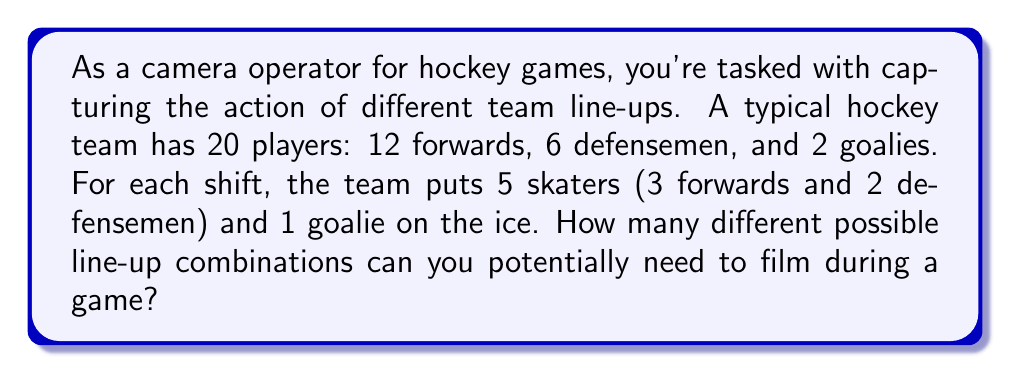Can you solve this math problem? Let's break this down step-by-step:

1) First, let's consider the forwards. We need to choose 3 out of 12 forwards.
   This can be done in $\binom{12}{3}$ ways.

2) For the defensemen, we need to choose 2 out of 6.
   This can be done in $\binom{6}{2}$ ways.

3) For the goalie, we need to choose 1 out of 2.
   This can be done in $\binom{2}{1}$ ways.

4) By the multiplication principle, the total number of possible line-ups is:

   $$ \binom{12}{3} \times \binom{6}{2} \times \binom{2}{1} $$

5) Let's calculate each combination:
   
   $\binom{12}{3} = \frac{12!}{3!(12-3)!} = \frac{12!}{3!9!} = 220$
   
   $\binom{6}{2} = \frac{6!}{2!(6-2)!} = \frac{6!}{2!4!} = 15$
   
   $\binom{2}{1} = \frac{2!}{1!(2-1)!} = \frac{2!}{1!1!} = 2$

6) Now, we multiply these numbers:

   $$ 220 \times 15 \times 2 = 6,600 $$

Therefore, there are 6,600 possible line-up combinations that you might need to film during a game.
Answer: 6,600 combinations 